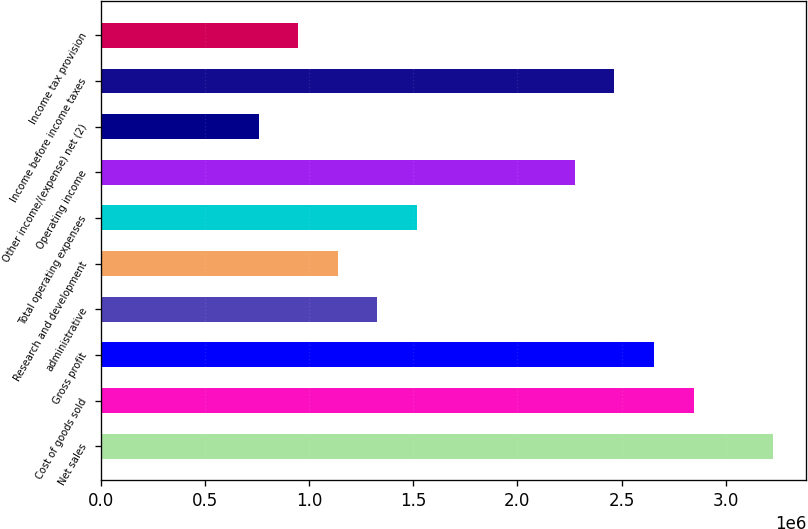Convert chart to OTSL. <chart><loc_0><loc_0><loc_500><loc_500><bar_chart><fcel>Net sales<fcel>Cost of goods sold<fcel>Gross profit<fcel>administrative<fcel>Research and development<fcel>Total operating expenses<fcel>Operating income<fcel>Other income/(expense) net (2)<fcel>Income before income taxes<fcel>Income tax provision<nl><fcel>3.22493e+06<fcel>2.84553e+06<fcel>2.65583e+06<fcel>1.32791e+06<fcel>1.13821e+06<fcel>1.51762e+06<fcel>2.27642e+06<fcel>758808<fcel>2.46613e+06<fcel>948510<nl></chart> 